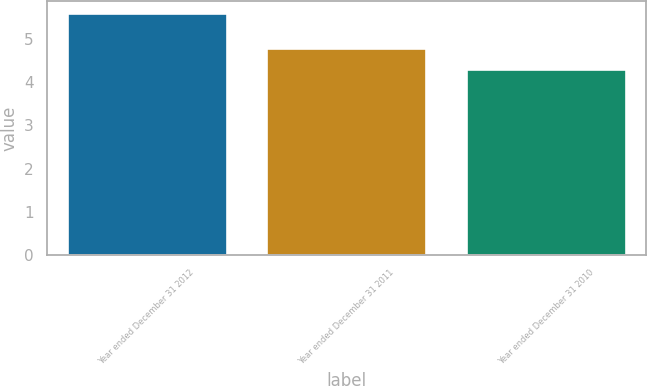Convert chart. <chart><loc_0><loc_0><loc_500><loc_500><bar_chart><fcel>Year ended December 31 2012<fcel>Year ended December 31 2011<fcel>Year ended December 31 2010<nl><fcel>5.6<fcel>4.8<fcel>4.3<nl></chart> 